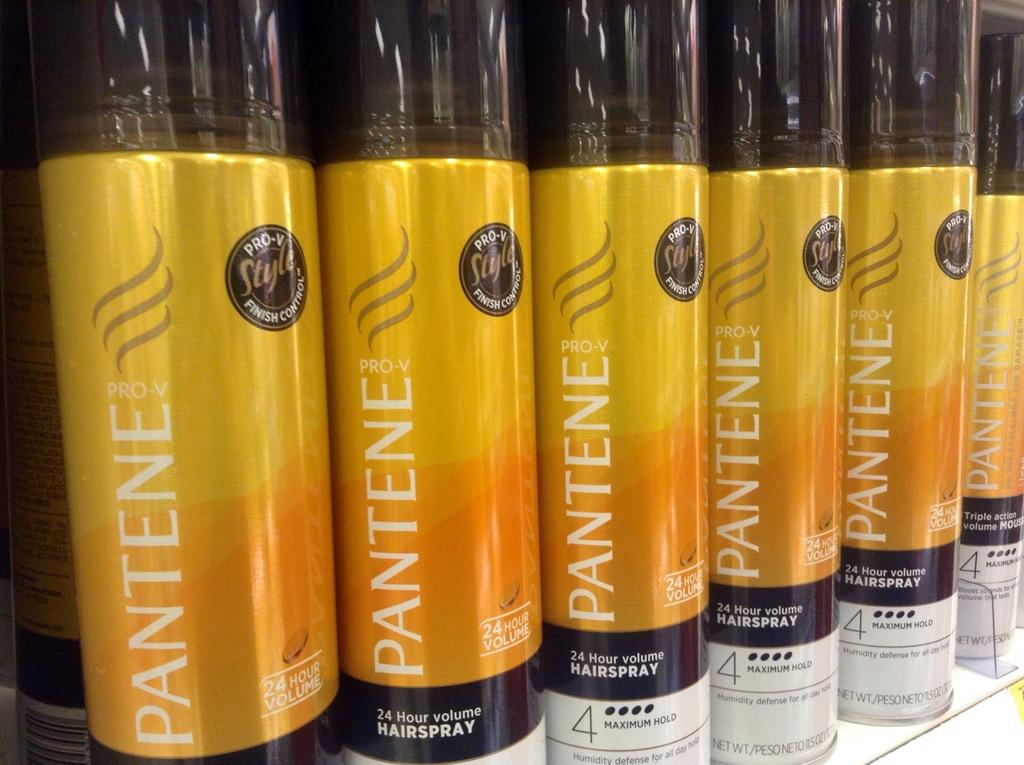Provide a one-sentence caption for the provided image. Many containers of Pantene hair spray sit on a shelf. 